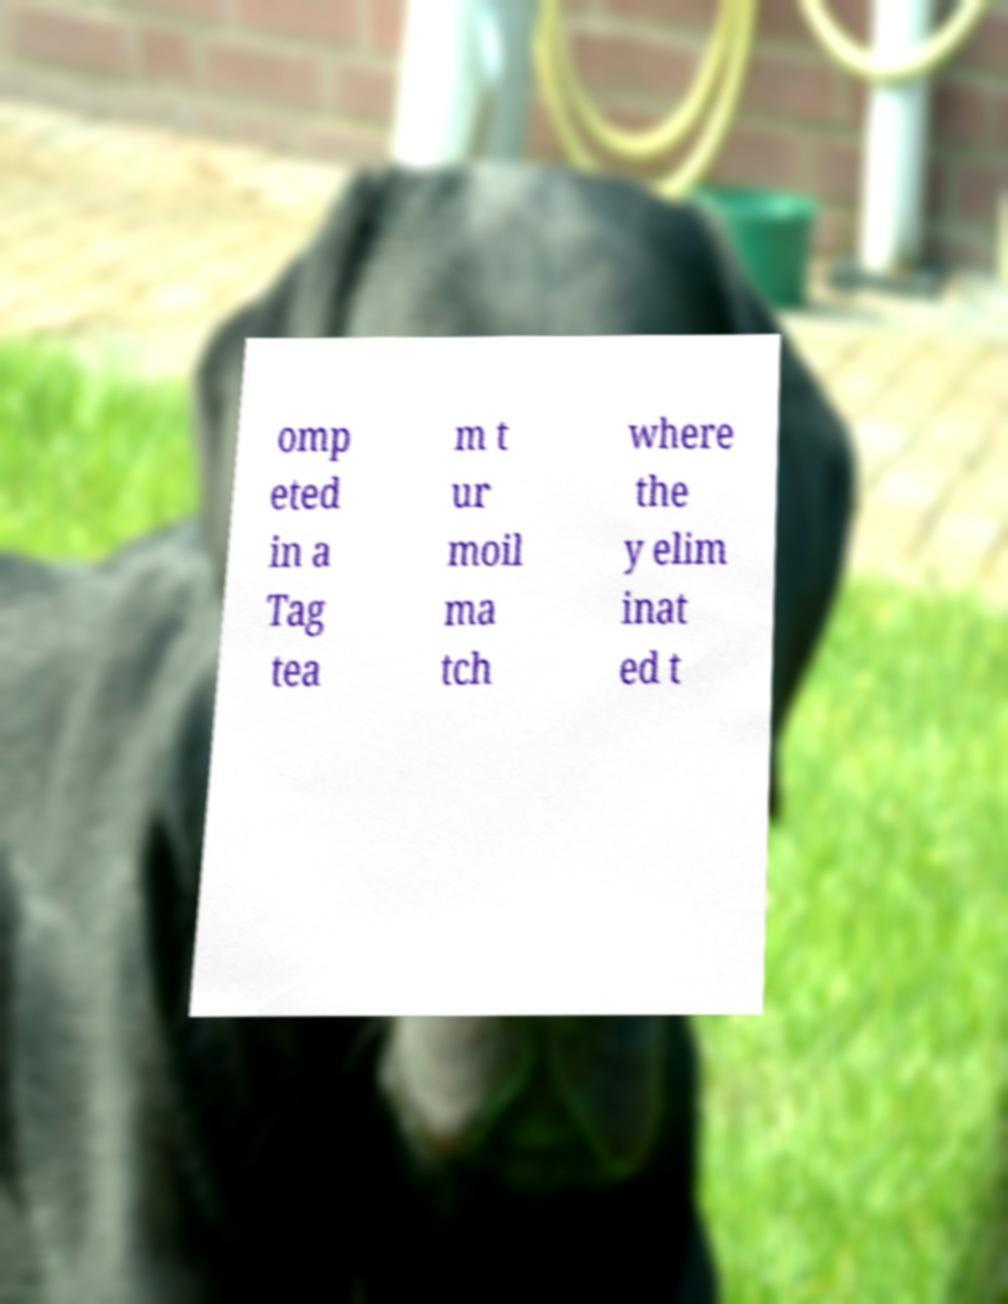Could you assist in decoding the text presented in this image and type it out clearly? omp eted in a Tag tea m t ur moil ma tch where the y elim inat ed t 